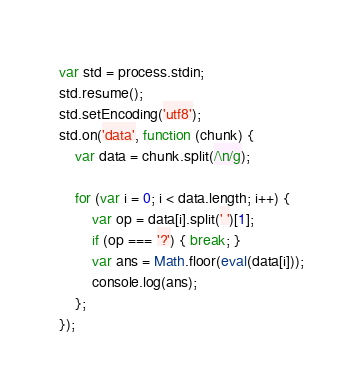<code> <loc_0><loc_0><loc_500><loc_500><_JavaScript_>var std = process.stdin;
std.resume();
std.setEncoding('utf8');
std.on('data', function (chunk) {
    var data = chunk.split(/\n/g);

    for (var i = 0; i < data.length; i++) {
        var op = data[i].split(' ')[1];
        if (op === '?') { break; }
        var ans = Math.floor(eval(data[i]));
        console.log(ans);
    };
});</code> 